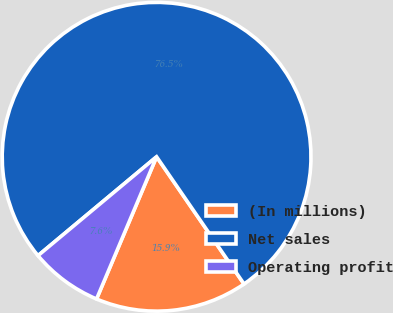Convert chart. <chart><loc_0><loc_0><loc_500><loc_500><pie_chart><fcel>(In millions)<fcel>Net sales<fcel>Operating profit<nl><fcel>15.94%<fcel>76.48%<fcel>7.58%<nl></chart> 